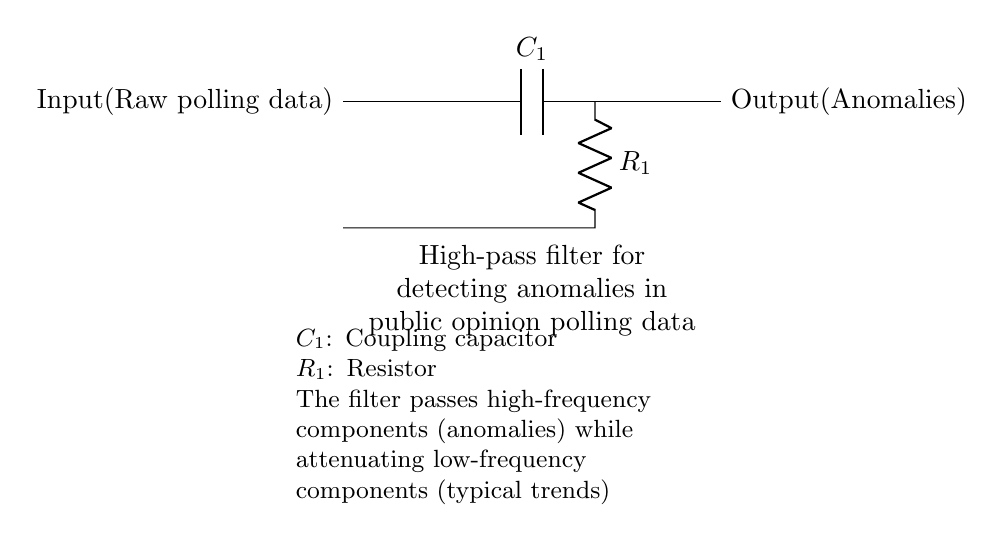What is the main function of this high-pass filter? The main function is to pass high-frequency components (anomalies) while attenuating low-frequency components (typical trends).
Answer: Detect anomalies What are the two main components in this circuit? The circuit contains a capacitor and a resistor, which are key in determining the filter's behavior and frequency response.
Answer: Capacitor and resistor What does the coupling capacitor do in this circuit? The coupling capacitor allows high-frequency signals to pass through while blocking low-frequency signals, thus facilitating the filtering process for anomaly detection.
Answer: Blocks low frequencies What is the role of the resistor in the high-pass filter? The resistor works with the capacitor to set the cutoff frequency of the filter, determining which signals are passed through and which are attenuated.
Answer: Sets cutoff frequency What should be observed at the output of the circuit? The output of the circuit should show the anomalies detected from the input raw polling data after filtering out typical trends.
Answer: Anomalies What type of signals does this high-pass filter primarily pass? The high-pass filter primarily passes high-frequency signals, which represent sudden changes or anomalies in the data.
Answer: High-frequency signals What is the purpose of isolating anomalies in public opinion polling data? Isolating anomalies helps lawmakers identify significant shifts in public opinion, enabling informed decision-making and adjustments to policies.
Answer: Inform decision-making 